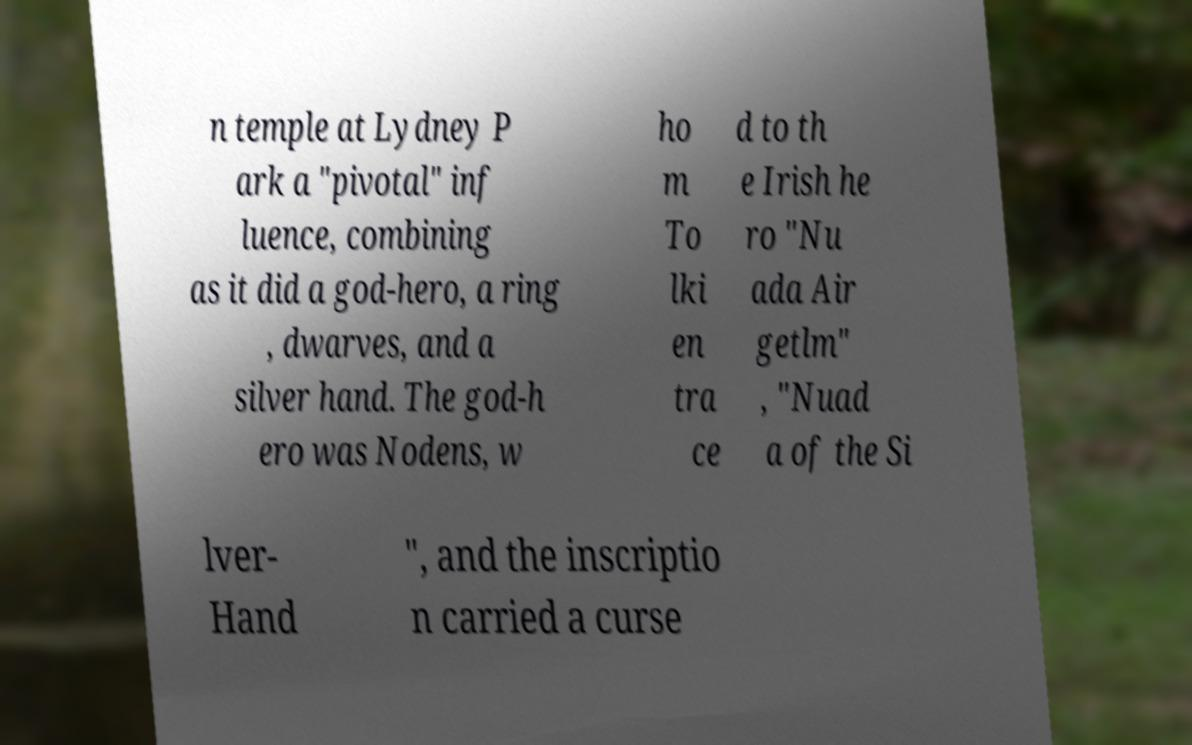Could you assist in decoding the text presented in this image and type it out clearly? n temple at Lydney P ark a "pivotal" inf luence, combining as it did a god-hero, a ring , dwarves, and a silver hand. The god-h ero was Nodens, w ho m To lki en tra ce d to th e Irish he ro "Nu ada Air getlm" , "Nuad a of the Si lver- Hand ", and the inscriptio n carried a curse 